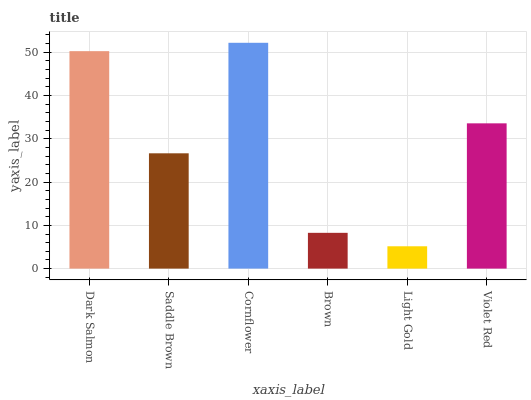Is Light Gold the minimum?
Answer yes or no. Yes. Is Cornflower the maximum?
Answer yes or no. Yes. Is Saddle Brown the minimum?
Answer yes or no. No. Is Saddle Brown the maximum?
Answer yes or no. No. Is Dark Salmon greater than Saddle Brown?
Answer yes or no. Yes. Is Saddle Brown less than Dark Salmon?
Answer yes or no. Yes. Is Saddle Brown greater than Dark Salmon?
Answer yes or no. No. Is Dark Salmon less than Saddle Brown?
Answer yes or no. No. Is Violet Red the high median?
Answer yes or no. Yes. Is Saddle Brown the low median?
Answer yes or no. Yes. Is Brown the high median?
Answer yes or no. No. Is Dark Salmon the low median?
Answer yes or no. No. 